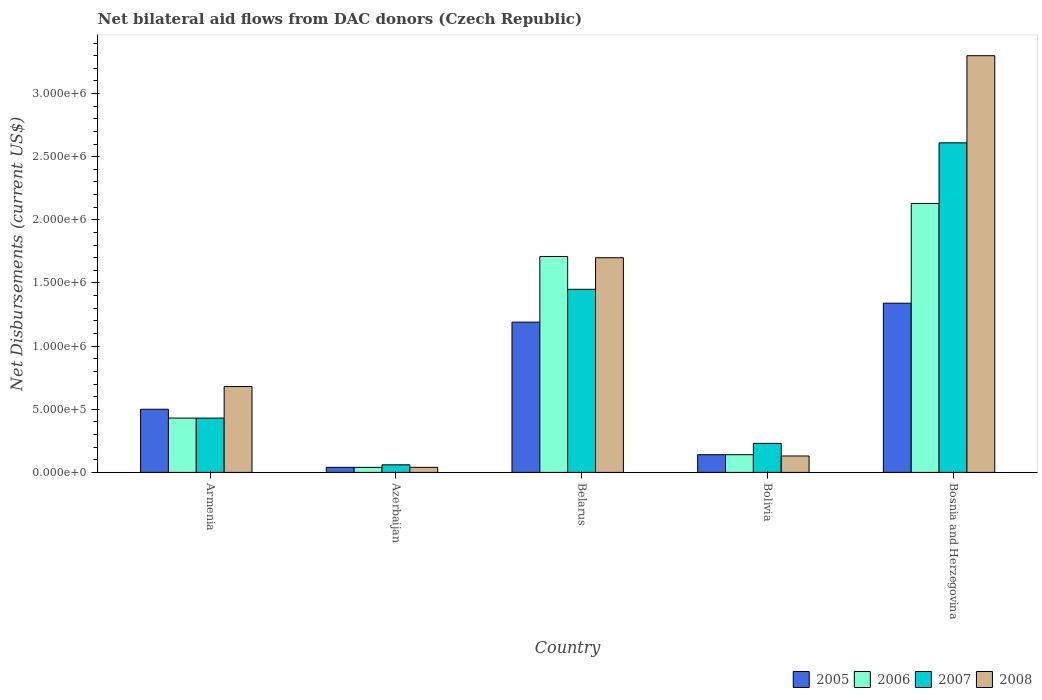Are the number of bars per tick equal to the number of legend labels?
Your response must be concise. Yes. How many bars are there on the 1st tick from the left?
Offer a very short reply. 4. Across all countries, what is the maximum net bilateral aid flows in 2005?
Your answer should be very brief. 1.34e+06. In which country was the net bilateral aid flows in 2008 maximum?
Your answer should be very brief. Bosnia and Herzegovina. In which country was the net bilateral aid flows in 2008 minimum?
Your response must be concise. Azerbaijan. What is the total net bilateral aid flows in 2007 in the graph?
Provide a short and direct response. 4.78e+06. What is the difference between the net bilateral aid flows in 2006 in Armenia and that in Bosnia and Herzegovina?
Ensure brevity in your answer.  -1.70e+06. What is the difference between the net bilateral aid flows in 2007 in Bolivia and the net bilateral aid flows in 2006 in Azerbaijan?
Give a very brief answer. 1.90e+05. What is the average net bilateral aid flows in 2008 per country?
Offer a terse response. 1.17e+06. What is the difference between the net bilateral aid flows of/in 2005 and net bilateral aid flows of/in 2007 in Bosnia and Herzegovina?
Make the answer very short. -1.27e+06. In how many countries, is the net bilateral aid flows in 2007 greater than 1800000 US$?
Ensure brevity in your answer.  1. What is the difference between the highest and the second highest net bilateral aid flows in 2008?
Offer a very short reply. 2.62e+06. What is the difference between the highest and the lowest net bilateral aid flows in 2008?
Offer a very short reply. 3.26e+06. In how many countries, is the net bilateral aid flows in 2005 greater than the average net bilateral aid flows in 2005 taken over all countries?
Keep it short and to the point. 2. What does the 3rd bar from the left in Azerbaijan represents?
Make the answer very short. 2007. What does the 1st bar from the right in Belarus represents?
Offer a very short reply. 2008. Are the values on the major ticks of Y-axis written in scientific E-notation?
Your response must be concise. Yes. Does the graph contain grids?
Offer a very short reply. No. What is the title of the graph?
Provide a short and direct response. Net bilateral aid flows from DAC donors (Czech Republic). What is the label or title of the Y-axis?
Keep it short and to the point. Net Disbursements (current US$). What is the Net Disbursements (current US$) of 2006 in Armenia?
Make the answer very short. 4.30e+05. What is the Net Disbursements (current US$) in 2008 in Armenia?
Provide a succinct answer. 6.80e+05. What is the Net Disbursements (current US$) of 2005 in Azerbaijan?
Your response must be concise. 4.00e+04. What is the Net Disbursements (current US$) in 2007 in Azerbaijan?
Your answer should be compact. 6.00e+04. What is the Net Disbursements (current US$) of 2008 in Azerbaijan?
Your answer should be compact. 4.00e+04. What is the Net Disbursements (current US$) of 2005 in Belarus?
Provide a short and direct response. 1.19e+06. What is the Net Disbursements (current US$) of 2006 in Belarus?
Your answer should be very brief. 1.71e+06. What is the Net Disbursements (current US$) in 2007 in Belarus?
Make the answer very short. 1.45e+06. What is the Net Disbursements (current US$) of 2008 in Belarus?
Your answer should be compact. 1.70e+06. What is the Net Disbursements (current US$) of 2005 in Bolivia?
Offer a very short reply. 1.40e+05. What is the Net Disbursements (current US$) in 2007 in Bolivia?
Keep it short and to the point. 2.30e+05. What is the Net Disbursements (current US$) in 2008 in Bolivia?
Your answer should be very brief. 1.30e+05. What is the Net Disbursements (current US$) in 2005 in Bosnia and Herzegovina?
Offer a very short reply. 1.34e+06. What is the Net Disbursements (current US$) in 2006 in Bosnia and Herzegovina?
Give a very brief answer. 2.13e+06. What is the Net Disbursements (current US$) of 2007 in Bosnia and Herzegovina?
Provide a short and direct response. 2.61e+06. What is the Net Disbursements (current US$) of 2008 in Bosnia and Herzegovina?
Ensure brevity in your answer.  3.30e+06. Across all countries, what is the maximum Net Disbursements (current US$) of 2005?
Your response must be concise. 1.34e+06. Across all countries, what is the maximum Net Disbursements (current US$) of 2006?
Offer a terse response. 2.13e+06. Across all countries, what is the maximum Net Disbursements (current US$) of 2007?
Give a very brief answer. 2.61e+06. Across all countries, what is the maximum Net Disbursements (current US$) in 2008?
Your response must be concise. 3.30e+06. Across all countries, what is the minimum Net Disbursements (current US$) of 2005?
Make the answer very short. 4.00e+04. Across all countries, what is the minimum Net Disbursements (current US$) in 2007?
Offer a very short reply. 6.00e+04. Across all countries, what is the minimum Net Disbursements (current US$) of 2008?
Your answer should be very brief. 4.00e+04. What is the total Net Disbursements (current US$) in 2005 in the graph?
Your response must be concise. 3.21e+06. What is the total Net Disbursements (current US$) in 2006 in the graph?
Give a very brief answer. 4.45e+06. What is the total Net Disbursements (current US$) of 2007 in the graph?
Offer a very short reply. 4.78e+06. What is the total Net Disbursements (current US$) of 2008 in the graph?
Offer a terse response. 5.85e+06. What is the difference between the Net Disbursements (current US$) of 2007 in Armenia and that in Azerbaijan?
Offer a very short reply. 3.70e+05. What is the difference between the Net Disbursements (current US$) of 2008 in Armenia and that in Azerbaijan?
Provide a succinct answer. 6.40e+05. What is the difference between the Net Disbursements (current US$) in 2005 in Armenia and that in Belarus?
Your answer should be very brief. -6.90e+05. What is the difference between the Net Disbursements (current US$) of 2006 in Armenia and that in Belarus?
Provide a short and direct response. -1.28e+06. What is the difference between the Net Disbursements (current US$) of 2007 in Armenia and that in Belarus?
Your response must be concise. -1.02e+06. What is the difference between the Net Disbursements (current US$) in 2008 in Armenia and that in Belarus?
Offer a very short reply. -1.02e+06. What is the difference between the Net Disbursements (current US$) of 2006 in Armenia and that in Bolivia?
Your answer should be compact. 2.90e+05. What is the difference between the Net Disbursements (current US$) of 2007 in Armenia and that in Bolivia?
Keep it short and to the point. 2.00e+05. What is the difference between the Net Disbursements (current US$) of 2005 in Armenia and that in Bosnia and Herzegovina?
Provide a short and direct response. -8.40e+05. What is the difference between the Net Disbursements (current US$) of 2006 in Armenia and that in Bosnia and Herzegovina?
Offer a very short reply. -1.70e+06. What is the difference between the Net Disbursements (current US$) in 2007 in Armenia and that in Bosnia and Herzegovina?
Offer a very short reply. -2.18e+06. What is the difference between the Net Disbursements (current US$) of 2008 in Armenia and that in Bosnia and Herzegovina?
Your response must be concise. -2.62e+06. What is the difference between the Net Disbursements (current US$) of 2005 in Azerbaijan and that in Belarus?
Offer a very short reply. -1.15e+06. What is the difference between the Net Disbursements (current US$) of 2006 in Azerbaijan and that in Belarus?
Your answer should be very brief. -1.67e+06. What is the difference between the Net Disbursements (current US$) in 2007 in Azerbaijan and that in Belarus?
Your response must be concise. -1.39e+06. What is the difference between the Net Disbursements (current US$) of 2008 in Azerbaijan and that in Belarus?
Ensure brevity in your answer.  -1.66e+06. What is the difference between the Net Disbursements (current US$) in 2005 in Azerbaijan and that in Bolivia?
Your response must be concise. -1.00e+05. What is the difference between the Net Disbursements (current US$) in 2006 in Azerbaijan and that in Bolivia?
Your answer should be compact. -1.00e+05. What is the difference between the Net Disbursements (current US$) of 2008 in Azerbaijan and that in Bolivia?
Your answer should be compact. -9.00e+04. What is the difference between the Net Disbursements (current US$) in 2005 in Azerbaijan and that in Bosnia and Herzegovina?
Your response must be concise. -1.30e+06. What is the difference between the Net Disbursements (current US$) of 2006 in Azerbaijan and that in Bosnia and Herzegovina?
Ensure brevity in your answer.  -2.09e+06. What is the difference between the Net Disbursements (current US$) in 2007 in Azerbaijan and that in Bosnia and Herzegovina?
Keep it short and to the point. -2.55e+06. What is the difference between the Net Disbursements (current US$) in 2008 in Azerbaijan and that in Bosnia and Herzegovina?
Offer a very short reply. -3.26e+06. What is the difference between the Net Disbursements (current US$) of 2005 in Belarus and that in Bolivia?
Give a very brief answer. 1.05e+06. What is the difference between the Net Disbursements (current US$) of 2006 in Belarus and that in Bolivia?
Offer a terse response. 1.57e+06. What is the difference between the Net Disbursements (current US$) in 2007 in Belarus and that in Bolivia?
Provide a short and direct response. 1.22e+06. What is the difference between the Net Disbursements (current US$) of 2008 in Belarus and that in Bolivia?
Your answer should be compact. 1.57e+06. What is the difference between the Net Disbursements (current US$) in 2005 in Belarus and that in Bosnia and Herzegovina?
Make the answer very short. -1.50e+05. What is the difference between the Net Disbursements (current US$) in 2006 in Belarus and that in Bosnia and Herzegovina?
Ensure brevity in your answer.  -4.20e+05. What is the difference between the Net Disbursements (current US$) in 2007 in Belarus and that in Bosnia and Herzegovina?
Ensure brevity in your answer.  -1.16e+06. What is the difference between the Net Disbursements (current US$) in 2008 in Belarus and that in Bosnia and Herzegovina?
Keep it short and to the point. -1.60e+06. What is the difference between the Net Disbursements (current US$) in 2005 in Bolivia and that in Bosnia and Herzegovina?
Make the answer very short. -1.20e+06. What is the difference between the Net Disbursements (current US$) in 2006 in Bolivia and that in Bosnia and Herzegovina?
Your answer should be compact. -1.99e+06. What is the difference between the Net Disbursements (current US$) of 2007 in Bolivia and that in Bosnia and Herzegovina?
Your answer should be very brief. -2.38e+06. What is the difference between the Net Disbursements (current US$) in 2008 in Bolivia and that in Bosnia and Herzegovina?
Your response must be concise. -3.17e+06. What is the difference between the Net Disbursements (current US$) of 2005 in Armenia and the Net Disbursements (current US$) of 2006 in Azerbaijan?
Your answer should be very brief. 4.60e+05. What is the difference between the Net Disbursements (current US$) of 2005 in Armenia and the Net Disbursements (current US$) of 2007 in Azerbaijan?
Give a very brief answer. 4.40e+05. What is the difference between the Net Disbursements (current US$) in 2005 in Armenia and the Net Disbursements (current US$) in 2008 in Azerbaijan?
Offer a terse response. 4.60e+05. What is the difference between the Net Disbursements (current US$) of 2006 in Armenia and the Net Disbursements (current US$) of 2007 in Azerbaijan?
Keep it short and to the point. 3.70e+05. What is the difference between the Net Disbursements (current US$) in 2006 in Armenia and the Net Disbursements (current US$) in 2008 in Azerbaijan?
Give a very brief answer. 3.90e+05. What is the difference between the Net Disbursements (current US$) in 2005 in Armenia and the Net Disbursements (current US$) in 2006 in Belarus?
Your answer should be very brief. -1.21e+06. What is the difference between the Net Disbursements (current US$) in 2005 in Armenia and the Net Disbursements (current US$) in 2007 in Belarus?
Give a very brief answer. -9.50e+05. What is the difference between the Net Disbursements (current US$) in 2005 in Armenia and the Net Disbursements (current US$) in 2008 in Belarus?
Offer a very short reply. -1.20e+06. What is the difference between the Net Disbursements (current US$) of 2006 in Armenia and the Net Disbursements (current US$) of 2007 in Belarus?
Your response must be concise. -1.02e+06. What is the difference between the Net Disbursements (current US$) in 2006 in Armenia and the Net Disbursements (current US$) in 2008 in Belarus?
Your answer should be compact. -1.27e+06. What is the difference between the Net Disbursements (current US$) in 2007 in Armenia and the Net Disbursements (current US$) in 2008 in Belarus?
Make the answer very short. -1.27e+06. What is the difference between the Net Disbursements (current US$) of 2005 in Armenia and the Net Disbursements (current US$) of 2007 in Bolivia?
Offer a very short reply. 2.70e+05. What is the difference between the Net Disbursements (current US$) in 2005 in Armenia and the Net Disbursements (current US$) in 2008 in Bolivia?
Your response must be concise. 3.70e+05. What is the difference between the Net Disbursements (current US$) of 2006 in Armenia and the Net Disbursements (current US$) of 2007 in Bolivia?
Offer a very short reply. 2.00e+05. What is the difference between the Net Disbursements (current US$) in 2006 in Armenia and the Net Disbursements (current US$) in 2008 in Bolivia?
Offer a terse response. 3.00e+05. What is the difference between the Net Disbursements (current US$) in 2007 in Armenia and the Net Disbursements (current US$) in 2008 in Bolivia?
Keep it short and to the point. 3.00e+05. What is the difference between the Net Disbursements (current US$) of 2005 in Armenia and the Net Disbursements (current US$) of 2006 in Bosnia and Herzegovina?
Offer a terse response. -1.63e+06. What is the difference between the Net Disbursements (current US$) of 2005 in Armenia and the Net Disbursements (current US$) of 2007 in Bosnia and Herzegovina?
Provide a short and direct response. -2.11e+06. What is the difference between the Net Disbursements (current US$) in 2005 in Armenia and the Net Disbursements (current US$) in 2008 in Bosnia and Herzegovina?
Ensure brevity in your answer.  -2.80e+06. What is the difference between the Net Disbursements (current US$) in 2006 in Armenia and the Net Disbursements (current US$) in 2007 in Bosnia and Herzegovina?
Offer a terse response. -2.18e+06. What is the difference between the Net Disbursements (current US$) in 2006 in Armenia and the Net Disbursements (current US$) in 2008 in Bosnia and Herzegovina?
Keep it short and to the point. -2.87e+06. What is the difference between the Net Disbursements (current US$) of 2007 in Armenia and the Net Disbursements (current US$) of 2008 in Bosnia and Herzegovina?
Your answer should be compact. -2.87e+06. What is the difference between the Net Disbursements (current US$) of 2005 in Azerbaijan and the Net Disbursements (current US$) of 2006 in Belarus?
Offer a terse response. -1.67e+06. What is the difference between the Net Disbursements (current US$) of 2005 in Azerbaijan and the Net Disbursements (current US$) of 2007 in Belarus?
Provide a succinct answer. -1.41e+06. What is the difference between the Net Disbursements (current US$) of 2005 in Azerbaijan and the Net Disbursements (current US$) of 2008 in Belarus?
Your answer should be very brief. -1.66e+06. What is the difference between the Net Disbursements (current US$) of 2006 in Azerbaijan and the Net Disbursements (current US$) of 2007 in Belarus?
Your answer should be compact. -1.41e+06. What is the difference between the Net Disbursements (current US$) in 2006 in Azerbaijan and the Net Disbursements (current US$) in 2008 in Belarus?
Provide a succinct answer. -1.66e+06. What is the difference between the Net Disbursements (current US$) in 2007 in Azerbaijan and the Net Disbursements (current US$) in 2008 in Belarus?
Your answer should be very brief. -1.64e+06. What is the difference between the Net Disbursements (current US$) in 2005 in Azerbaijan and the Net Disbursements (current US$) in 2008 in Bolivia?
Your answer should be compact. -9.00e+04. What is the difference between the Net Disbursements (current US$) of 2005 in Azerbaijan and the Net Disbursements (current US$) of 2006 in Bosnia and Herzegovina?
Offer a very short reply. -2.09e+06. What is the difference between the Net Disbursements (current US$) in 2005 in Azerbaijan and the Net Disbursements (current US$) in 2007 in Bosnia and Herzegovina?
Your answer should be very brief. -2.57e+06. What is the difference between the Net Disbursements (current US$) in 2005 in Azerbaijan and the Net Disbursements (current US$) in 2008 in Bosnia and Herzegovina?
Give a very brief answer. -3.26e+06. What is the difference between the Net Disbursements (current US$) of 2006 in Azerbaijan and the Net Disbursements (current US$) of 2007 in Bosnia and Herzegovina?
Keep it short and to the point. -2.57e+06. What is the difference between the Net Disbursements (current US$) in 2006 in Azerbaijan and the Net Disbursements (current US$) in 2008 in Bosnia and Herzegovina?
Your answer should be very brief. -3.26e+06. What is the difference between the Net Disbursements (current US$) of 2007 in Azerbaijan and the Net Disbursements (current US$) of 2008 in Bosnia and Herzegovina?
Offer a terse response. -3.24e+06. What is the difference between the Net Disbursements (current US$) of 2005 in Belarus and the Net Disbursements (current US$) of 2006 in Bolivia?
Ensure brevity in your answer.  1.05e+06. What is the difference between the Net Disbursements (current US$) in 2005 in Belarus and the Net Disbursements (current US$) in 2007 in Bolivia?
Keep it short and to the point. 9.60e+05. What is the difference between the Net Disbursements (current US$) in 2005 in Belarus and the Net Disbursements (current US$) in 2008 in Bolivia?
Your answer should be very brief. 1.06e+06. What is the difference between the Net Disbursements (current US$) in 2006 in Belarus and the Net Disbursements (current US$) in 2007 in Bolivia?
Provide a succinct answer. 1.48e+06. What is the difference between the Net Disbursements (current US$) in 2006 in Belarus and the Net Disbursements (current US$) in 2008 in Bolivia?
Offer a terse response. 1.58e+06. What is the difference between the Net Disbursements (current US$) in 2007 in Belarus and the Net Disbursements (current US$) in 2008 in Bolivia?
Offer a terse response. 1.32e+06. What is the difference between the Net Disbursements (current US$) in 2005 in Belarus and the Net Disbursements (current US$) in 2006 in Bosnia and Herzegovina?
Keep it short and to the point. -9.40e+05. What is the difference between the Net Disbursements (current US$) of 2005 in Belarus and the Net Disbursements (current US$) of 2007 in Bosnia and Herzegovina?
Provide a short and direct response. -1.42e+06. What is the difference between the Net Disbursements (current US$) in 2005 in Belarus and the Net Disbursements (current US$) in 2008 in Bosnia and Herzegovina?
Give a very brief answer. -2.11e+06. What is the difference between the Net Disbursements (current US$) in 2006 in Belarus and the Net Disbursements (current US$) in 2007 in Bosnia and Herzegovina?
Provide a short and direct response. -9.00e+05. What is the difference between the Net Disbursements (current US$) in 2006 in Belarus and the Net Disbursements (current US$) in 2008 in Bosnia and Herzegovina?
Provide a succinct answer. -1.59e+06. What is the difference between the Net Disbursements (current US$) in 2007 in Belarus and the Net Disbursements (current US$) in 2008 in Bosnia and Herzegovina?
Your response must be concise. -1.85e+06. What is the difference between the Net Disbursements (current US$) in 2005 in Bolivia and the Net Disbursements (current US$) in 2006 in Bosnia and Herzegovina?
Give a very brief answer. -1.99e+06. What is the difference between the Net Disbursements (current US$) of 2005 in Bolivia and the Net Disbursements (current US$) of 2007 in Bosnia and Herzegovina?
Provide a short and direct response. -2.47e+06. What is the difference between the Net Disbursements (current US$) of 2005 in Bolivia and the Net Disbursements (current US$) of 2008 in Bosnia and Herzegovina?
Give a very brief answer. -3.16e+06. What is the difference between the Net Disbursements (current US$) in 2006 in Bolivia and the Net Disbursements (current US$) in 2007 in Bosnia and Herzegovina?
Your answer should be compact. -2.47e+06. What is the difference between the Net Disbursements (current US$) of 2006 in Bolivia and the Net Disbursements (current US$) of 2008 in Bosnia and Herzegovina?
Keep it short and to the point. -3.16e+06. What is the difference between the Net Disbursements (current US$) of 2007 in Bolivia and the Net Disbursements (current US$) of 2008 in Bosnia and Herzegovina?
Provide a succinct answer. -3.07e+06. What is the average Net Disbursements (current US$) in 2005 per country?
Your answer should be compact. 6.42e+05. What is the average Net Disbursements (current US$) of 2006 per country?
Ensure brevity in your answer.  8.90e+05. What is the average Net Disbursements (current US$) in 2007 per country?
Offer a terse response. 9.56e+05. What is the average Net Disbursements (current US$) in 2008 per country?
Provide a succinct answer. 1.17e+06. What is the difference between the Net Disbursements (current US$) of 2005 and Net Disbursements (current US$) of 2006 in Armenia?
Your response must be concise. 7.00e+04. What is the difference between the Net Disbursements (current US$) of 2005 and Net Disbursements (current US$) of 2007 in Armenia?
Ensure brevity in your answer.  7.00e+04. What is the difference between the Net Disbursements (current US$) in 2006 and Net Disbursements (current US$) in 2007 in Armenia?
Provide a short and direct response. 0. What is the difference between the Net Disbursements (current US$) of 2007 and Net Disbursements (current US$) of 2008 in Armenia?
Ensure brevity in your answer.  -2.50e+05. What is the difference between the Net Disbursements (current US$) in 2005 and Net Disbursements (current US$) in 2006 in Azerbaijan?
Offer a terse response. 0. What is the difference between the Net Disbursements (current US$) in 2005 and Net Disbursements (current US$) in 2007 in Azerbaijan?
Offer a terse response. -2.00e+04. What is the difference between the Net Disbursements (current US$) of 2005 and Net Disbursements (current US$) of 2008 in Azerbaijan?
Ensure brevity in your answer.  0. What is the difference between the Net Disbursements (current US$) in 2005 and Net Disbursements (current US$) in 2006 in Belarus?
Your answer should be very brief. -5.20e+05. What is the difference between the Net Disbursements (current US$) in 2005 and Net Disbursements (current US$) in 2008 in Belarus?
Offer a very short reply. -5.10e+05. What is the difference between the Net Disbursements (current US$) of 2006 and Net Disbursements (current US$) of 2007 in Belarus?
Your answer should be very brief. 2.60e+05. What is the difference between the Net Disbursements (current US$) of 2007 and Net Disbursements (current US$) of 2008 in Belarus?
Offer a very short reply. -2.50e+05. What is the difference between the Net Disbursements (current US$) in 2005 and Net Disbursements (current US$) in 2007 in Bolivia?
Keep it short and to the point. -9.00e+04. What is the difference between the Net Disbursements (current US$) of 2005 and Net Disbursements (current US$) of 2008 in Bolivia?
Give a very brief answer. 10000. What is the difference between the Net Disbursements (current US$) of 2006 and Net Disbursements (current US$) of 2007 in Bolivia?
Make the answer very short. -9.00e+04. What is the difference between the Net Disbursements (current US$) in 2005 and Net Disbursements (current US$) in 2006 in Bosnia and Herzegovina?
Provide a short and direct response. -7.90e+05. What is the difference between the Net Disbursements (current US$) of 2005 and Net Disbursements (current US$) of 2007 in Bosnia and Herzegovina?
Your response must be concise. -1.27e+06. What is the difference between the Net Disbursements (current US$) in 2005 and Net Disbursements (current US$) in 2008 in Bosnia and Herzegovina?
Offer a terse response. -1.96e+06. What is the difference between the Net Disbursements (current US$) of 2006 and Net Disbursements (current US$) of 2007 in Bosnia and Herzegovina?
Provide a succinct answer. -4.80e+05. What is the difference between the Net Disbursements (current US$) of 2006 and Net Disbursements (current US$) of 2008 in Bosnia and Herzegovina?
Your answer should be compact. -1.17e+06. What is the difference between the Net Disbursements (current US$) of 2007 and Net Disbursements (current US$) of 2008 in Bosnia and Herzegovina?
Keep it short and to the point. -6.90e+05. What is the ratio of the Net Disbursements (current US$) of 2005 in Armenia to that in Azerbaijan?
Your answer should be very brief. 12.5. What is the ratio of the Net Disbursements (current US$) of 2006 in Armenia to that in Azerbaijan?
Keep it short and to the point. 10.75. What is the ratio of the Net Disbursements (current US$) in 2007 in Armenia to that in Azerbaijan?
Give a very brief answer. 7.17. What is the ratio of the Net Disbursements (current US$) in 2008 in Armenia to that in Azerbaijan?
Your response must be concise. 17. What is the ratio of the Net Disbursements (current US$) of 2005 in Armenia to that in Belarus?
Your answer should be compact. 0.42. What is the ratio of the Net Disbursements (current US$) in 2006 in Armenia to that in Belarus?
Your answer should be very brief. 0.25. What is the ratio of the Net Disbursements (current US$) in 2007 in Armenia to that in Belarus?
Offer a very short reply. 0.3. What is the ratio of the Net Disbursements (current US$) of 2005 in Armenia to that in Bolivia?
Ensure brevity in your answer.  3.57. What is the ratio of the Net Disbursements (current US$) of 2006 in Armenia to that in Bolivia?
Keep it short and to the point. 3.07. What is the ratio of the Net Disbursements (current US$) in 2007 in Armenia to that in Bolivia?
Your response must be concise. 1.87. What is the ratio of the Net Disbursements (current US$) of 2008 in Armenia to that in Bolivia?
Keep it short and to the point. 5.23. What is the ratio of the Net Disbursements (current US$) of 2005 in Armenia to that in Bosnia and Herzegovina?
Your response must be concise. 0.37. What is the ratio of the Net Disbursements (current US$) in 2006 in Armenia to that in Bosnia and Herzegovina?
Ensure brevity in your answer.  0.2. What is the ratio of the Net Disbursements (current US$) in 2007 in Armenia to that in Bosnia and Herzegovina?
Your answer should be compact. 0.16. What is the ratio of the Net Disbursements (current US$) of 2008 in Armenia to that in Bosnia and Herzegovina?
Your answer should be compact. 0.21. What is the ratio of the Net Disbursements (current US$) of 2005 in Azerbaijan to that in Belarus?
Your answer should be compact. 0.03. What is the ratio of the Net Disbursements (current US$) in 2006 in Azerbaijan to that in Belarus?
Keep it short and to the point. 0.02. What is the ratio of the Net Disbursements (current US$) in 2007 in Azerbaijan to that in Belarus?
Provide a short and direct response. 0.04. What is the ratio of the Net Disbursements (current US$) in 2008 in Azerbaijan to that in Belarus?
Ensure brevity in your answer.  0.02. What is the ratio of the Net Disbursements (current US$) in 2005 in Azerbaijan to that in Bolivia?
Offer a very short reply. 0.29. What is the ratio of the Net Disbursements (current US$) in 2006 in Azerbaijan to that in Bolivia?
Give a very brief answer. 0.29. What is the ratio of the Net Disbursements (current US$) of 2007 in Azerbaijan to that in Bolivia?
Provide a short and direct response. 0.26. What is the ratio of the Net Disbursements (current US$) in 2008 in Azerbaijan to that in Bolivia?
Provide a succinct answer. 0.31. What is the ratio of the Net Disbursements (current US$) in 2005 in Azerbaijan to that in Bosnia and Herzegovina?
Your response must be concise. 0.03. What is the ratio of the Net Disbursements (current US$) of 2006 in Azerbaijan to that in Bosnia and Herzegovina?
Offer a terse response. 0.02. What is the ratio of the Net Disbursements (current US$) in 2007 in Azerbaijan to that in Bosnia and Herzegovina?
Offer a terse response. 0.02. What is the ratio of the Net Disbursements (current US$) in 2008 in Azerbaijan to that in Bosnia and Herzegovina?
Your answer should be very brief. 0.01. What is the ratio of the Net Disbursements (current US$) in 2005 in Belarus to that in Bolivia?
Your response must be concise. 8.5. What is the ratio of the Net Disbursements (current US$) of 2006 in Belarus to that in Bolivia?
Offer a terse response. 12.21. What is the ratio of the Net Disbursements (current US$) of 2007 in Belarus to that in Bolivia?
Keep it short and to the point. 6.3. What is the ratio of the Net Disbursements (current US$) of 2008 in Belarus to that in Bolivia?
Your answer should be compact. 13.08. What is the ratio of the Net Disbursements (current US$) in 2005 in Belarus to that in Bosnia and Herzegovina?
Offer a very short reply. 0.89. What is the ratio of the Net Disbursements (current US$) in 2006 in Belarus to that in Bosnia and Herzegovina?
Give a very brief answer. 0.8. What is the ratio of the Net Disbursements (current US$) in 2007 in Belarus to that in Bosnia and Herzegovina?
Give a very brief answer. 0.56. What is the ratio of the Net Disbursements (current US$) in 2008 in Belarus to that in Bosnia and Herzegovina?
Give a very brief answer. 0.52. What is the ratio of the Net Disbursements (current US$) in 2005 in Bolivia to that in Bosnia and Herzegovina?
Provide a succinct answer. 0.1. What is the ratio of the Net Disbursements (current US$) of 2006 in Bolivia to that in Bosnia and Herzegovina?
Offer a terse response. 0.07. What is the ratio of the Net Disbursements (current US$) of 2007 in Bolivia to that in Bosnia and Herzegovina?
Your response must be concise. 0.09. What is the ratio of the Net Disbursements (current US$) in 2008 in Bolivia to that in Bosnia and Herzegovina?
Keep it short and to the point. 0.04. What is the difference between the highest and the second highest Net Disbursements (current US$) in 2005?
Make the answer very short. 1.50e+05. What is the difference between the highest and the second highest Net Disbursements (current US$) of 2007?
Provide a short and direct response. 1.16e+06. What is the difference between the highest and the second highest Net Disbursements (current US$) of 2008?
Offer a terse response. 1.60e+06. What is the difference between the highest and the lowest Net Disbursements (current US$) in 2005?
Give a very brief answer. 1.30e+06. What is the difference between the highest and the lowest Net Disbursements (current US$) of 2006?
Offer a very short reply. 2.09e+06. What is the difference between the highest and the lowest Net Disbursements (current US$) of 2007?
Your response must be concise. 2.55e+06. What is the difference between the highest and the lowest Net Disbursements (current US$) in 2008?
Make the answer very short. 3.26e+06. 